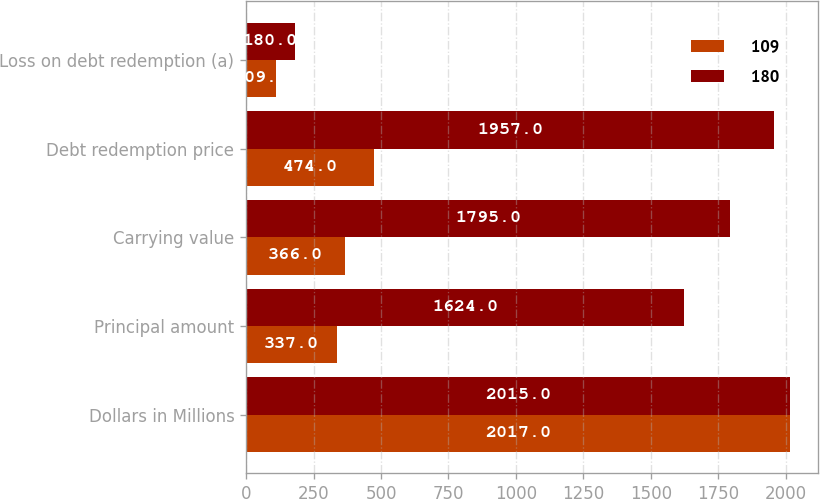Convert chart. <chart><loc_0><loc_0><loc_500><loc_500><stacked_bar_chart><ecel><fcel>Dollars in Millions<fcel>Principal amount<fcel>Carrying value<fcel>Debt redemption price<fcel>Loss on debt redemption (a)<nl><fcel>109<fcel>2017<fcel>337<fcel>366<fcel>474<fcel>109<nl><fcel>180<fcel>2015<fcel>1624<fcel>1795<fcel>1957<fcel>180<nl></chart> 